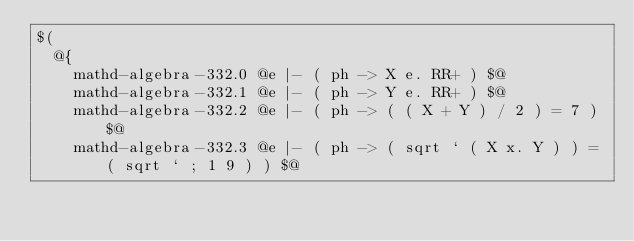<code> <loc_0><loc_0><loc_500><loc_500><_ObjectiveC_>$(
  @{
    mathd-algebra-332.0 @e |- ( ph -> X e. RR+ ) $@
    mathd-algebra-332.1 @e |- ( ph -> Y e. RR+ ) $@
    mathd-algebra-332.2 @e |- ( ph -> ( ( X + Y ) / 2 ) = 7 ) $@
    mathd-algebra-332.3 @e |- ( ph -> ( sqrt ` ( X x. Y ) ) = ( sqrt ` ; 1 9 ) ) $@</code> 